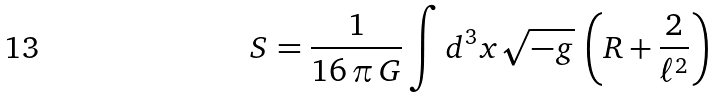<formula> <loc_0><loc_0><loc_500><loc_500>S = \frac { 1 } { 1 6 \, \pi \, G } \int d ^ { 3 } x \sqrt { - g } \, \left ( R + \frac { 2 } { \ell ^ { 2 } } \right )</formula> 